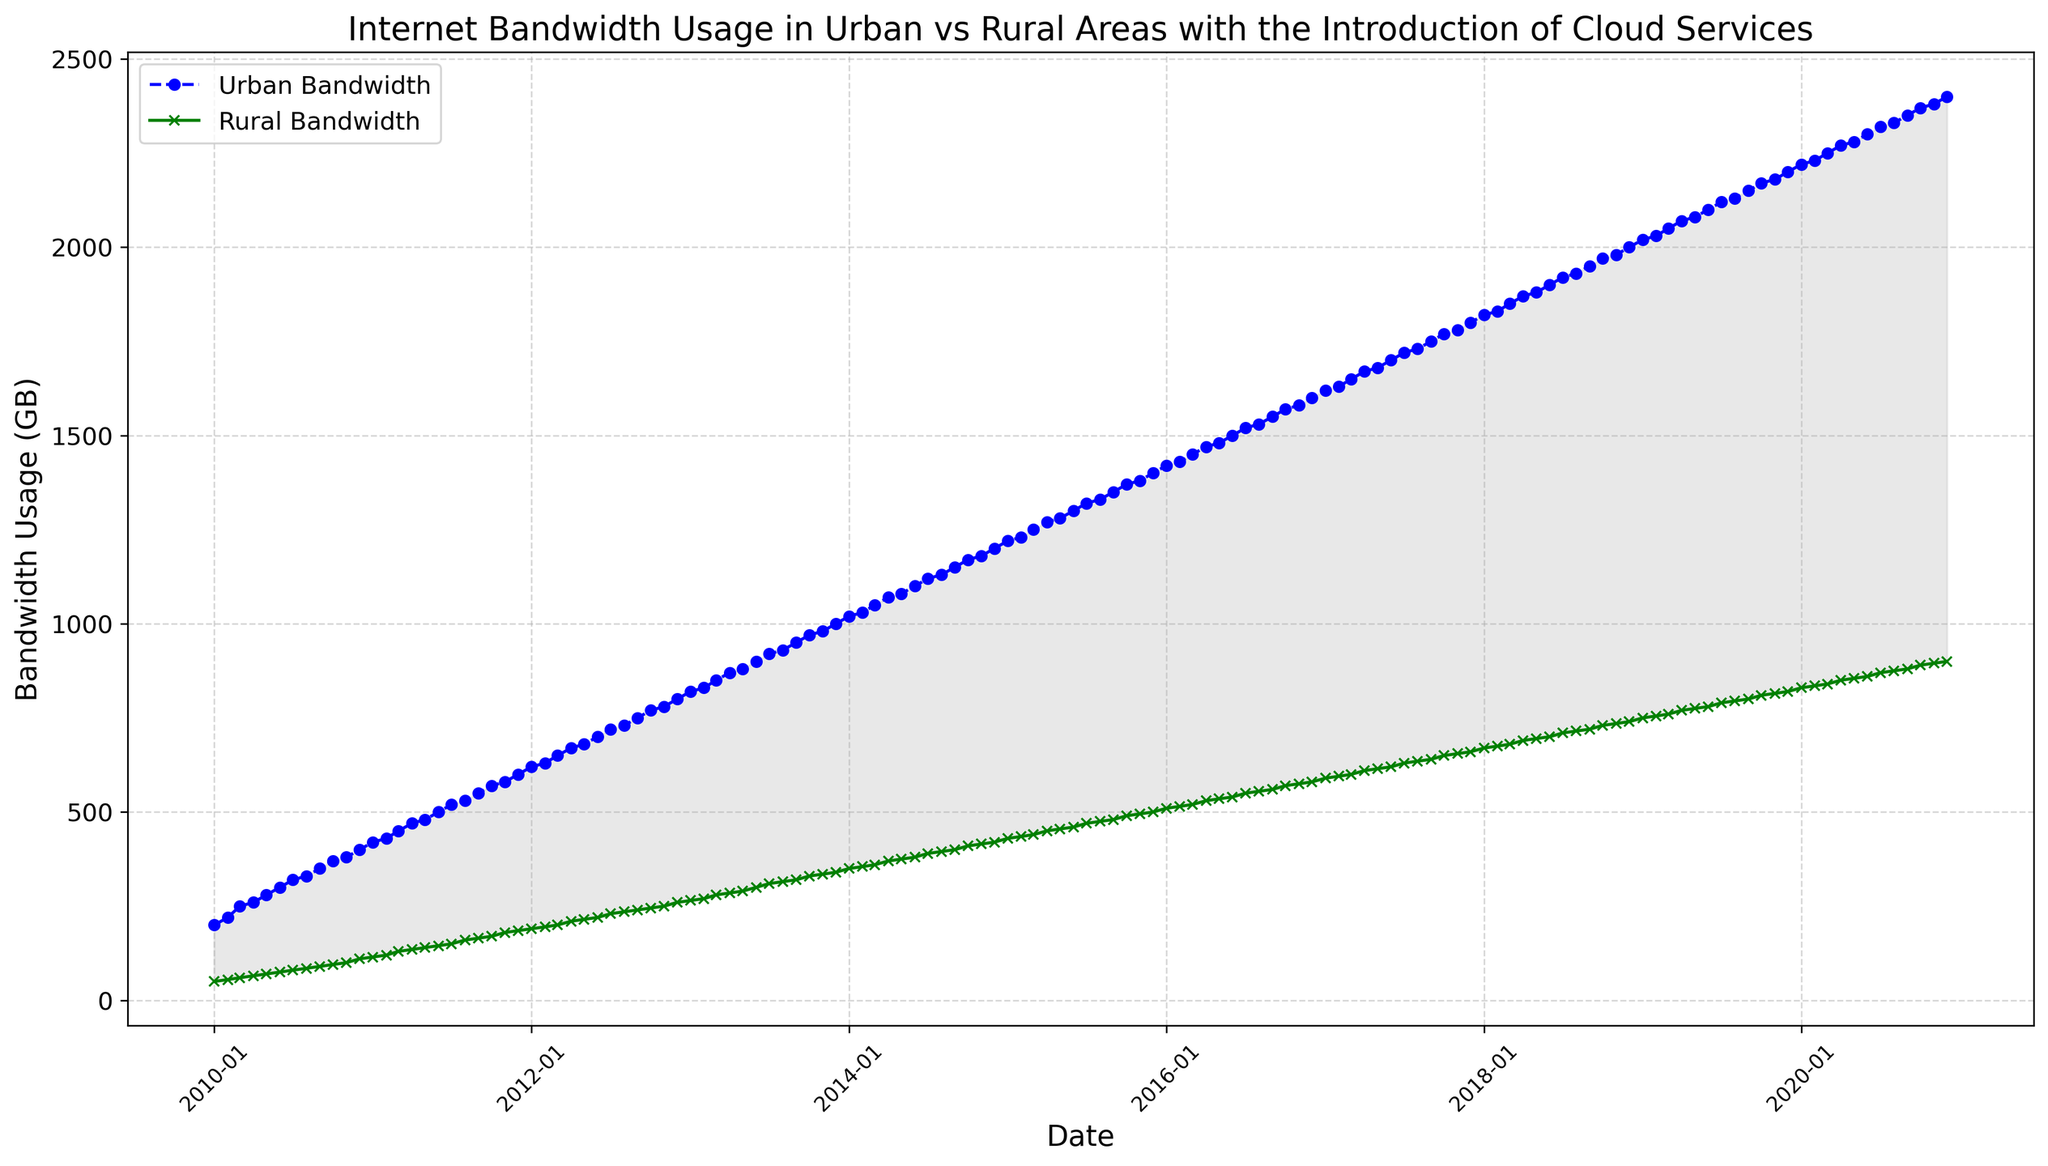How does the difference in bandwidth usage between urban and rural areas change over time? To determine this, we look at the gap between the two lines over the plot's timeframe. Initially, in 2010, the urban bandwidth usage is significantly higher than the rural one, around 150 GB more. This gap grows consistently over time, reaching about 1500 GB by 2020
Answer: The difference increases over time In which year does urban bandwidth usage first exceed 1000 GB? We observe the point where the urban bandwidth line first crosses the 1000 GB mark on the y-axis. This happens just at the beginning of 2014
Answer: 2014 What is the difference in rural bandwidth usage between 2015 and 2016? To find this, subtract the rural bandwidth value in 2015 from that in 2016. From the chart, the value in 2015 seems to be 500 GB, and in 2016 it is 540 GB. The difference is 540 - 500 = 40 GB
Answer: 40 GB Compare the trend lines of urban and rural bandwidth: Do they ever intersect? Examining the trends, the urban bandwidth usage (blue line) always remains above the rural bandwidth usage (green line) throughout the entire period from 2010 to 2020
Answer: No What month and year do both urban and rural bandwidth usages increase more rapidly? Look for the steepest slopes in both the blue and green lines. This happens around early 2020 for both lines, indicating a more rapid increase during January - April 2020
Answer: January - April 2020 What is the average urban bandwidth usage for the year 2018? Identify data points for each month in 2018, then sum them up and divide by 12. Values for 2018: 1820, 1830, 1850, 1870, 1880, 1900, 1920, 1930, 1950, 1970, 1980, 2000. So, (1820+1830+1850+1870+1880+1900+1920+1930+1950+1970+1980+2000)/12 = 1904.167
Answer: 1904.167 